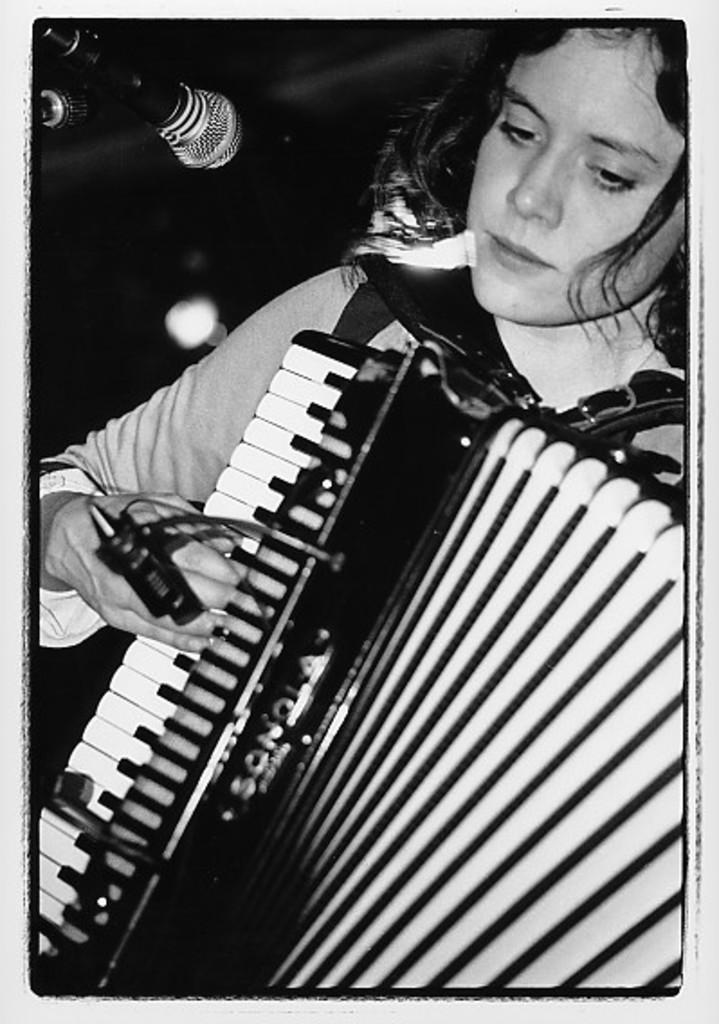What is the color scheme of the image? The image is black and white. Who is present in the image? There is a lady in the image. What is the lady holding in the image? The lady is holding a musical instrument. What other object can be seen in the image related to performing? There is a microphone in the image. What is the background of the image like? The background of the image is dark. What can be seen in the image that provides illumination? There are lights visible in the image. Can you tell me how many donkeys are present in the image? There are no donkeys present in the image. What type of vest is the lady wearing in the image? The image is black and white, and there is no indication of a vest being worn by the lady. 